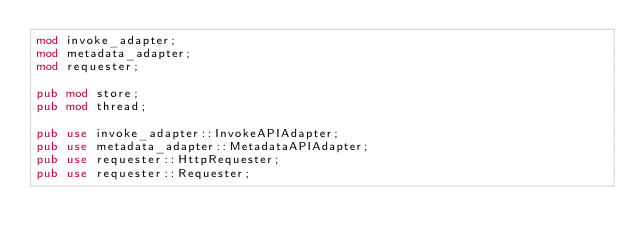Convert code to text. <code><loc_0><loc_0><loc_500><loc_500><_Rust_>mod invoke_adapter;
mod metadata_adapter;
mod requester;

pub mod store;
pub mod thread;

pub use invoke_adapter::InvokeAPIAdapter;
pub use metadata_adapter::MetadataAPIAdapter;
pub use requester::HttpRequester;
pub use requester::Requester;
</code> 